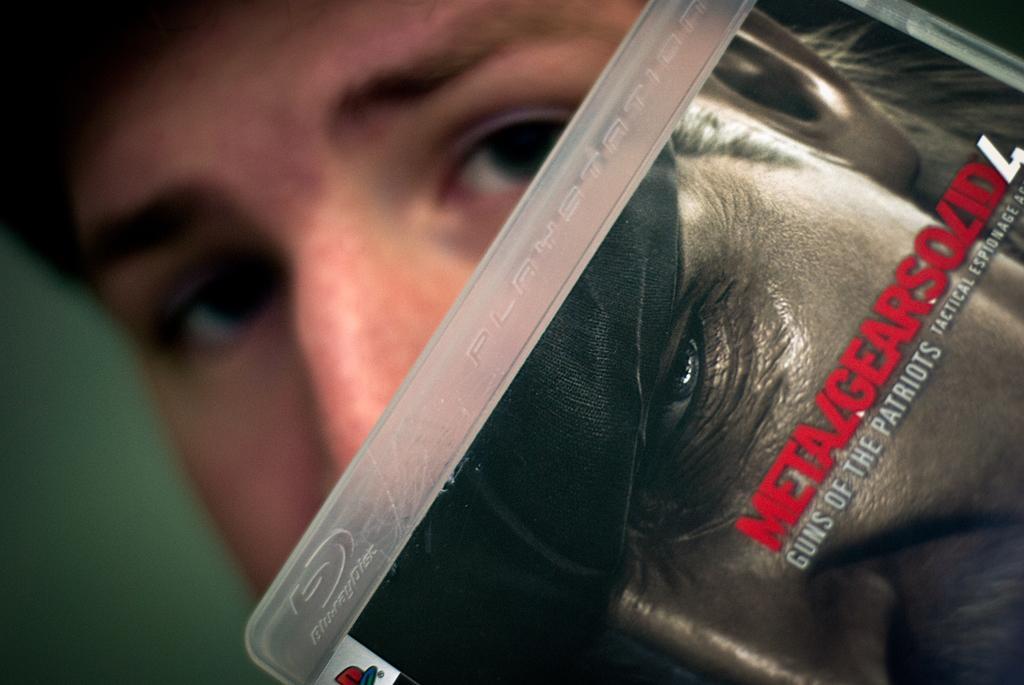Could you give a brief overview of what you see in this image? In this image there is a person posing with a PlayStation CD. 